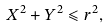<formula> <loc_0><loc_0><loc_500><loc_500>X ^ { 2 } + Y ^ { 2 } \leqslant r ^ { 2 } ,</formula> 